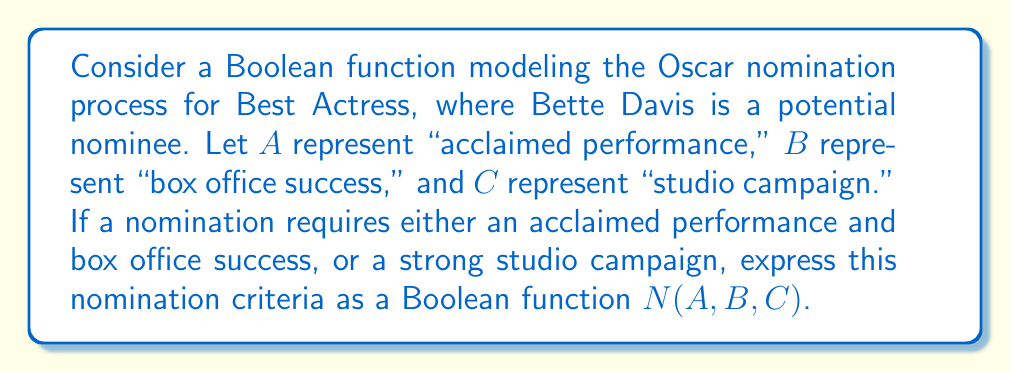Could you help me with this problem? Let's approach this step-by-step:

1) We need to model two scenarios that can lead to a nomination:
   a) Acclaimed performance AND box office success
   b) Strong studio campaign

2) Scenario (a) can be represented as: $A \wedge B$
   Where $\wedge$ represents the AND operation

3) Scenario (b) is simply represented by $C$

4) Since either of these scenarios can lead to a nomination, we connect them with an OR operation, represented by $\vee$

5) Therefore, the Boolean function for nomination is:
   $N(A,B,C) = (A \wedge B) \vee C$

6) This can be read as: "Nomination occurs if (Acclaimed performance AND Box office success) OR Studio campaign"

7) In the context of Bette Davis, this function would determine whether she receives a nomination based on these criteria for any given year or performance.
Answer: $N(A,B,C) = (A \wedge B) \vee C$ 